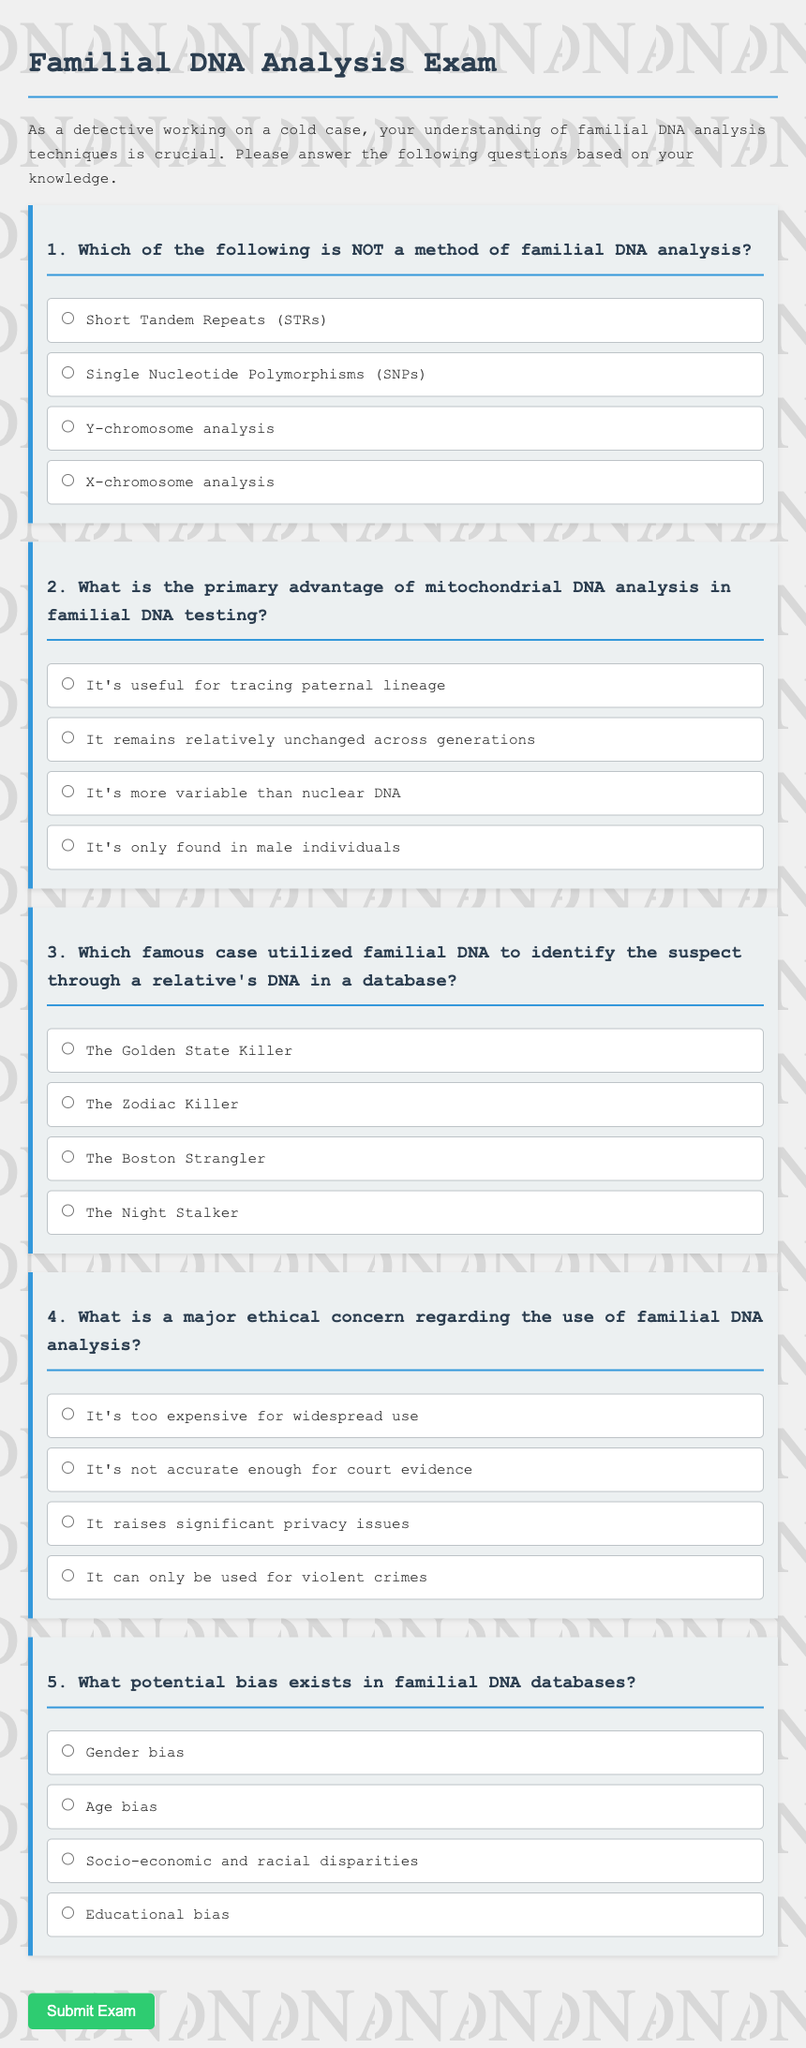What is the title of the document? The title of the document is provided in the HTML head section as "Familial DNA Analysis Exam."
Answer: Familial DNA Analysis Exam What is the primary purpose of the exam? The exam's purpose is described in the introductory paragraph, emphasizing the importance of understanding familial DNA analysis techniques for detectives.
Answer: Understanding familial DNA analysis techniques Which type of DNA analysis is labeled as NOT a method? The question specifically asks for the option that is NOT a method, which is identified through the question and options provided.
Answer: X-chromosome analysis How many questions are there in total in the exam? The document outlines five distinct questions in the exam, each addressing different aspects of familial DNA analysis.
Answer: 5 What major ethical concern is mentioned regarding familial DNA analysis? The ethical concern listed among the options, requiring selection based on the context of the questions provided.
Answer: Privacy issues Which case is referred to as utilizing familial DNA for suspect identification? This is found in one of the questions, highlighting a famous case known for using familial DNA methods.
Answer: The Golden State Killer 